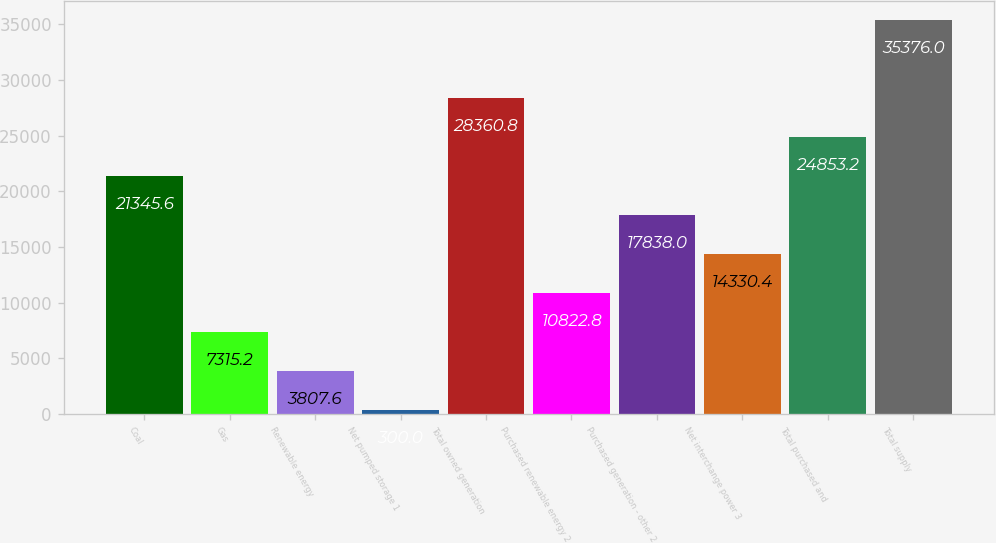Convert chart. <chart><loc_0><loc_0><loc_500><loc_500><bar_chart><fcel>Coal<fcel>Gas<fcel>Renewable energy<fcel>Net pumped storage 1<fcel>Total owned generation<fcel>Purchased renewable energy 2<fcel>Purchased generation - other 2<fcel>Net interchange power 3<fcel>Total purchased and<fcel>Total supply<nl><fcel>21345.6<fcel>7315.2<fcel>3807.6<fcel>300<fcel>28360.8<fcel>10822.8<fcel>17838<fcel>14330.4<fcel>24853.2<fcel>35376<nl></chart> 